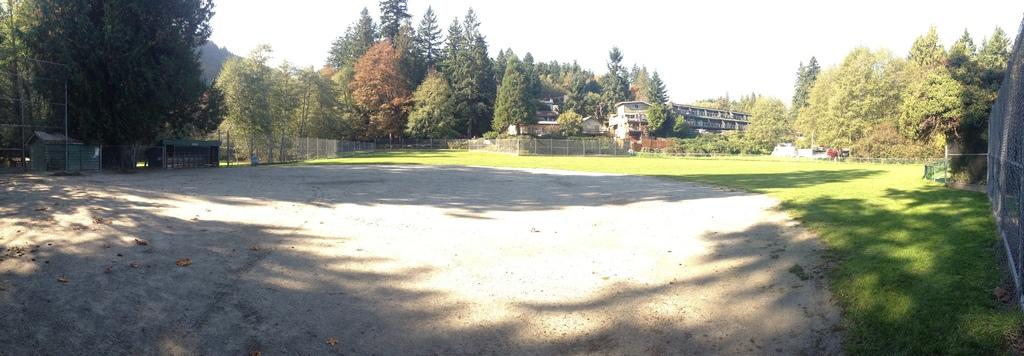What type of vegetation can be seen in the image? There are trees in the image. What type of structures are visible in the image? There are buildings in the image. What can be seen in the background of the image? The sky is visible in the background of the image. What is on the left side of the image? There is a fence on the left side of the image. What are the poles used for in the image? The purpose of the poles is not specified in the image. What type of ground surface is present in the image? Grass is present on the ground in the image. What other objects are on the ground in the image? There are other objects on the ground in the image, but their specific nature is not mentioned in the facts. What is the taste of the thing on the right side of the image? There is no "thing" mentioned on the right side of the image, and therefore no taste can be attributed to it. 